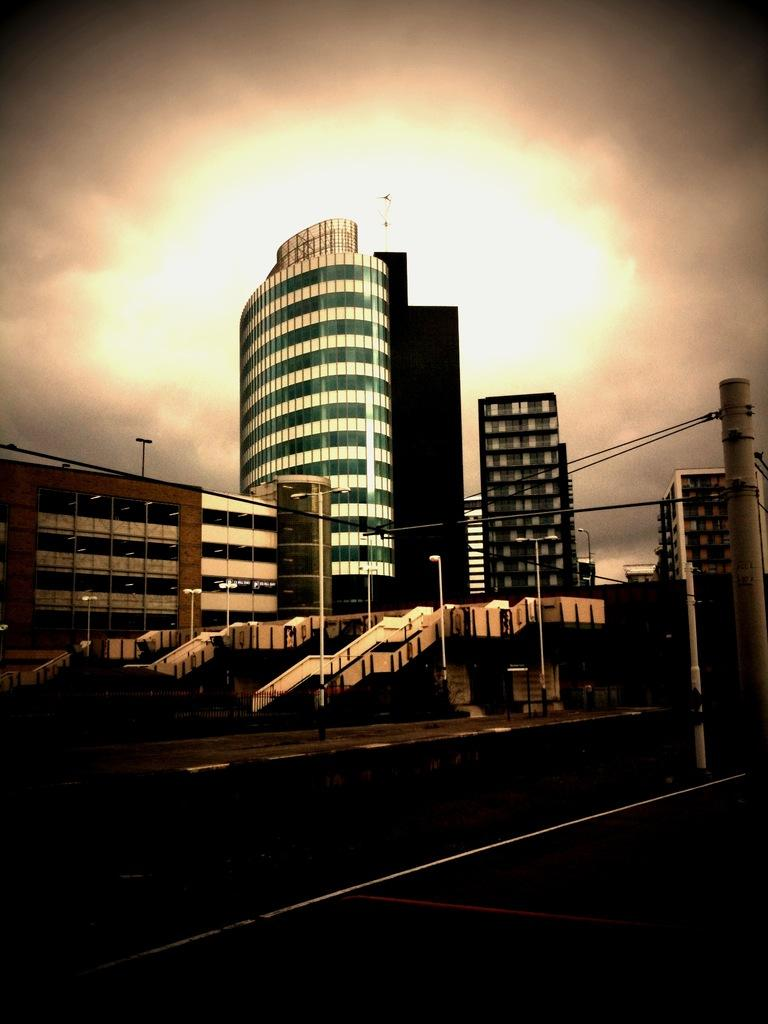What type of structures can be seen in the image? There are buildings in the image. What type of lighting is present in the image? Street lights are present in the image. What type of object can be seen supporting the wires? There is an iron pole in the image. What type of infrastructure is visible in the image? Wires are visible in the image. What can be seen in the background of the image? The sky is visible in the background of the image. What type of comfort can be seen in the image? There is no specific comfort item present in the image; it features buildings, street lights, an iron pole, wires, and the sky. When did the birth of the street lights occur in the image? The image does not provide information about the birth of the street lights; it only shows their presence. 